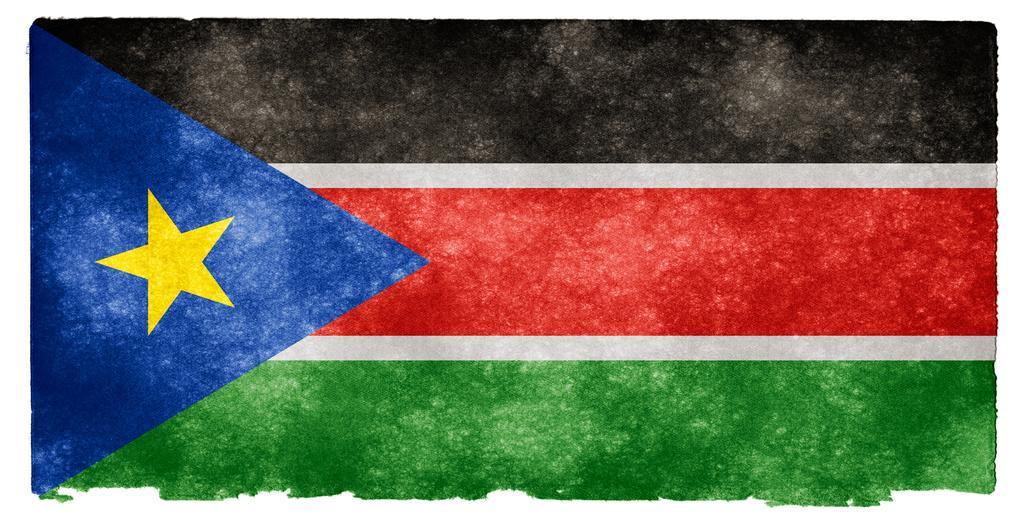In one or two sentences, can you explain what this image depicts? In this image we can see the picture of the flag. 